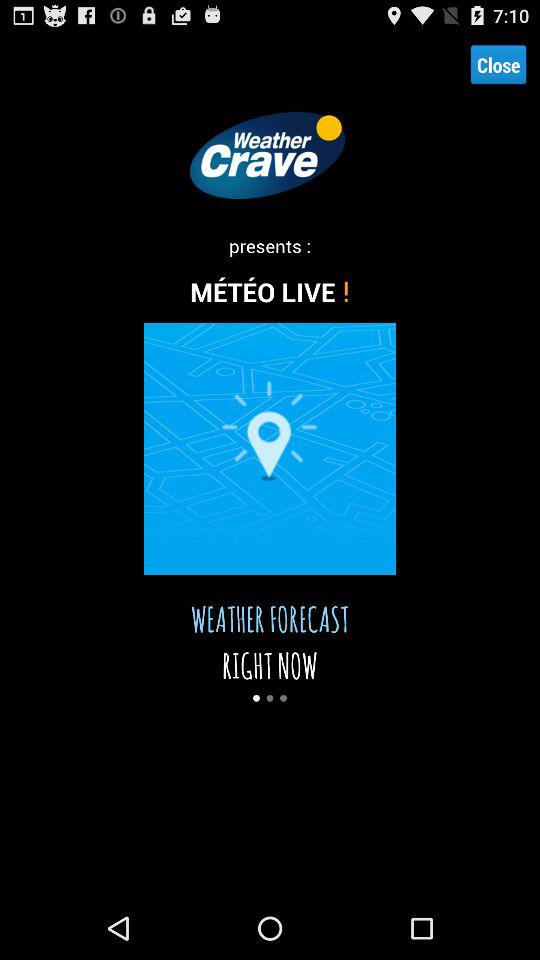What is the name of the application? The application name is "Weather Crave". 